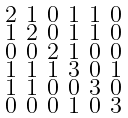Convert formula to latex. <formula><loc_0><loc_0><loc_500><loc_500>\begin{smallmatrix} 2 & 1 & 0 & 1 & 1 & 0 \\ 1 & 2 & 0 & 1 & 1 & 0 \\ 0 & 0 & 2 & 1 & 0 & 0 \\ 1 & 1 & 1 & 3 & 0 & 1 \\ 1 & 1 & 0 & 0 & 3 & 0 \\ 0 & 0 & 0 & 1 & 0 & 3 \end{smallmatrix}</formula> 